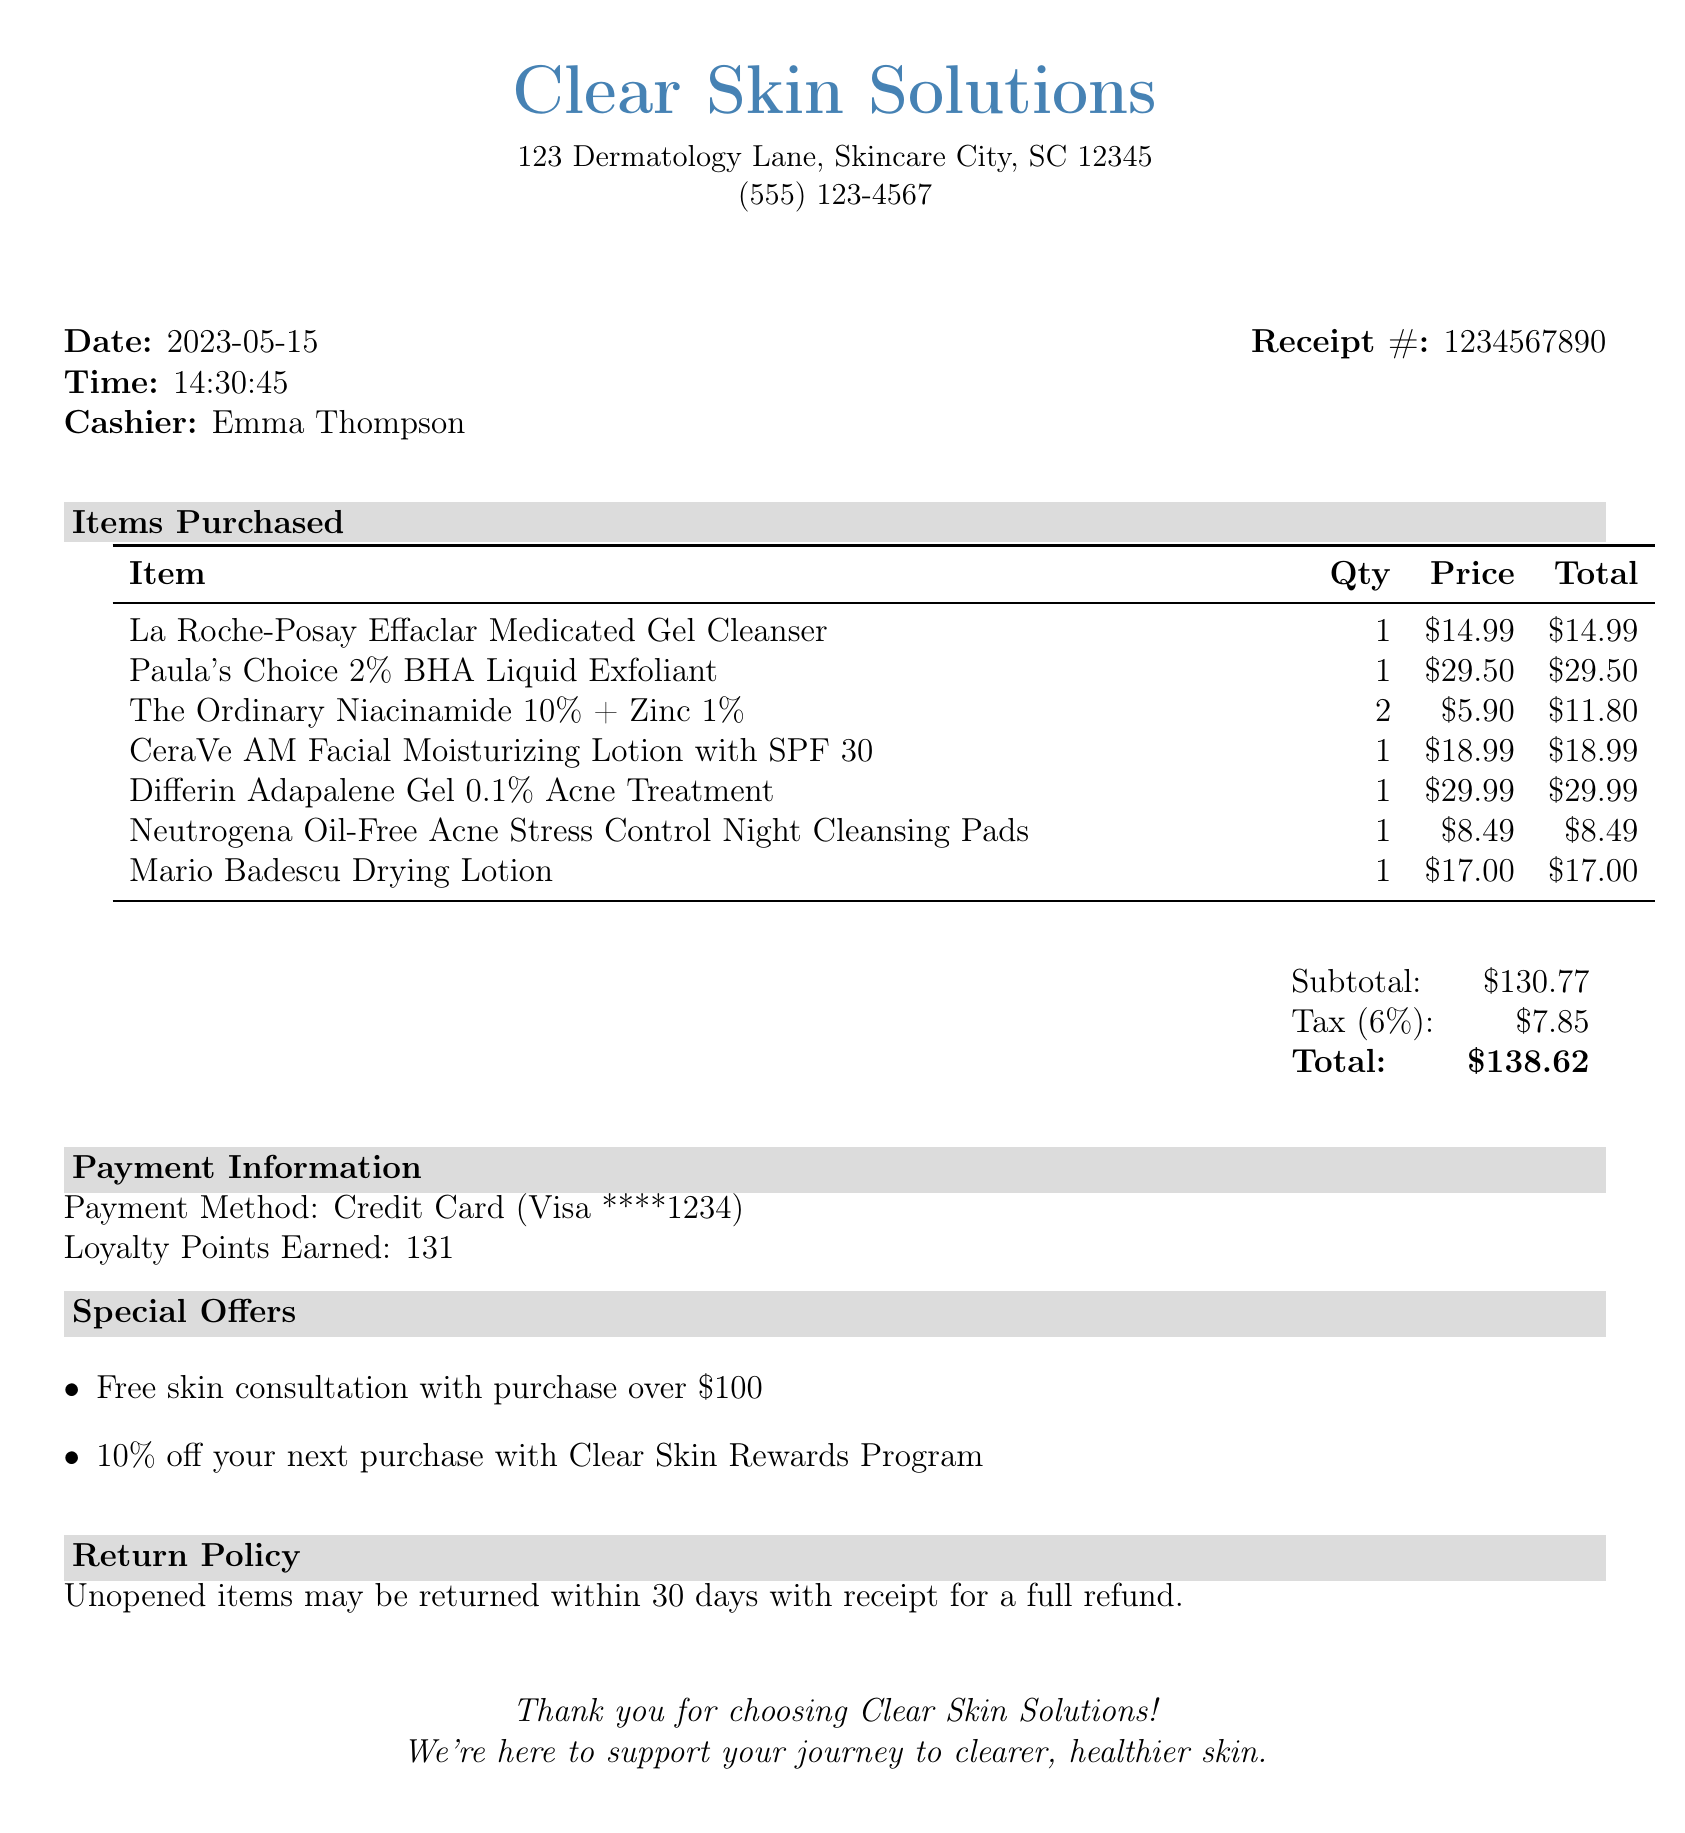What is the store name? The store name is prominently displayed at the top of the receipt.
Answer: Clear Skin Solutions What is the date of purchase? The date of purchase is clearly mentioned in the document.
Answer: 2023-05-15 How many loyalty points were earned? The earned loyalty points are specified in the payment information section of the receipt.
Answer: 131 What item has the highest price? The prices of the items are listed, and the item with the highest price can be identified from that list.
Answer: Paula's Choice 2% BHA Liquid Exfoliant What is the return policy? The return policy is described in a dedicated section at the bottom of the receipt.
Answer: Unopened items may be returned within 30 days with receipt for a full refund What was the total amount spent? The total amount spent is summarized at the end of the receipt under the total section.
Answer: $138.62 Which payment method was used? The payment method is stated in the payment information section of the receipt.
Answer: Credit Card What is the tax amount? The tax amount is calculated and provided in the totals section of the receipt.
Answer: $7.85 Was there a special offer associated with the purchase? Special offers are listed under a specific section in the document detailing discounts available.
Answer: Free skin consultation with purchase over $100 